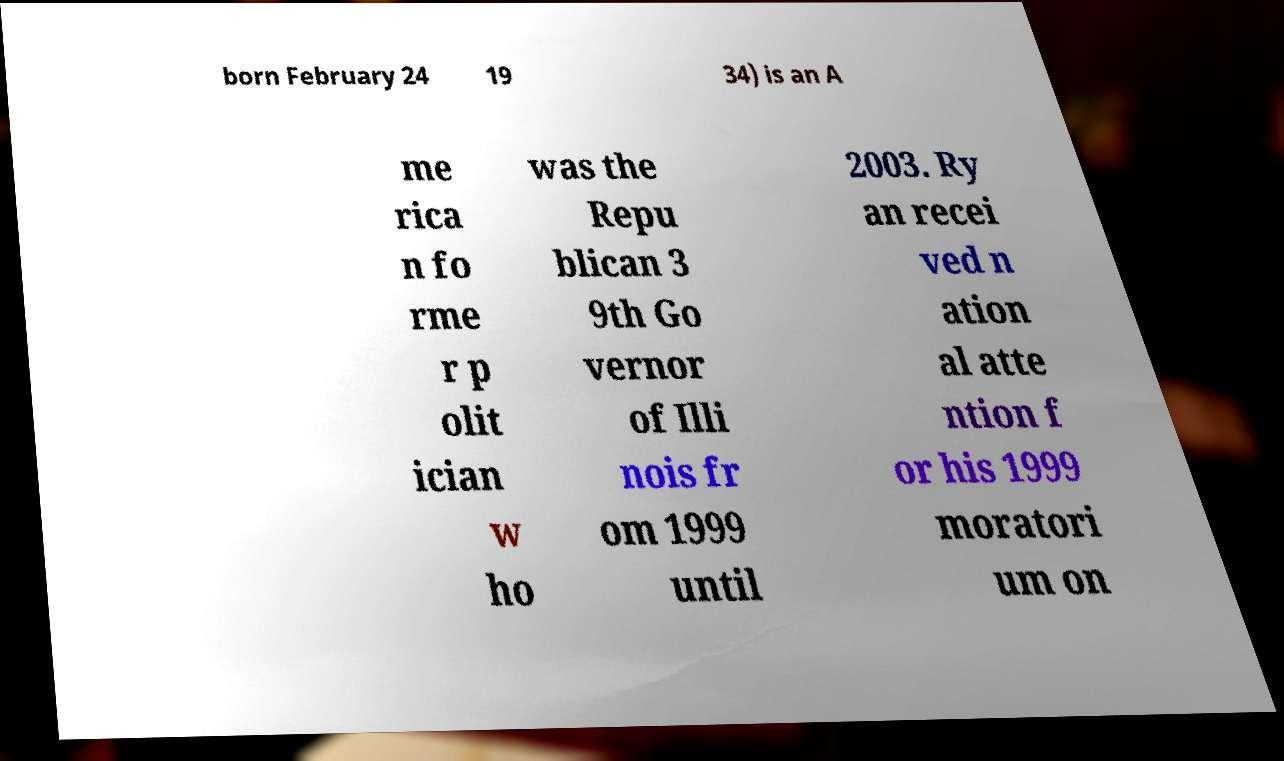Could you extract and type out the text from this image? born February 24 19 34) is an A me rica n fo rme r p olit ician w ho was the Repu blican 3 9th Go vernor of Illi nois fr om 1999 until 2003. Ry an recei ved n ation al atte ntion f or his 1999 moratori um on 